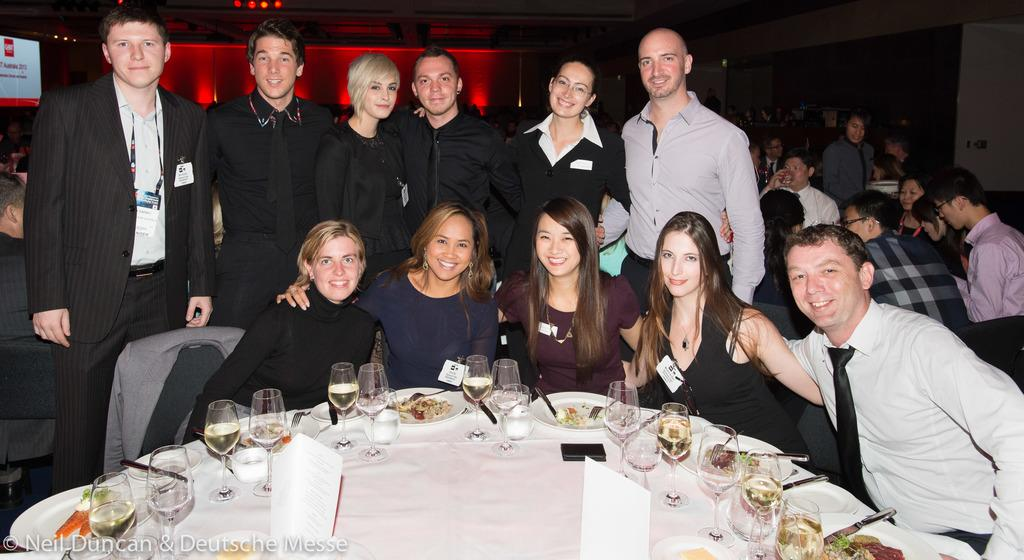How many girls are sitting around the dining table in the image? There are four girls sitting around the dining table in the image. What can be said about the appearance of the girls? The girls are described as beautiful. What is on the dining table besides the girls? There are wine glasses on the dining table. What are the people standing behind the girls doing? These people are laughing. What type of jelly is being served as a side dish with the meal in the image? There is no mention of jelly or a meal in the image; it features four girls sitting around a dining table with wine glasses and people standing behind them who are laughing. 